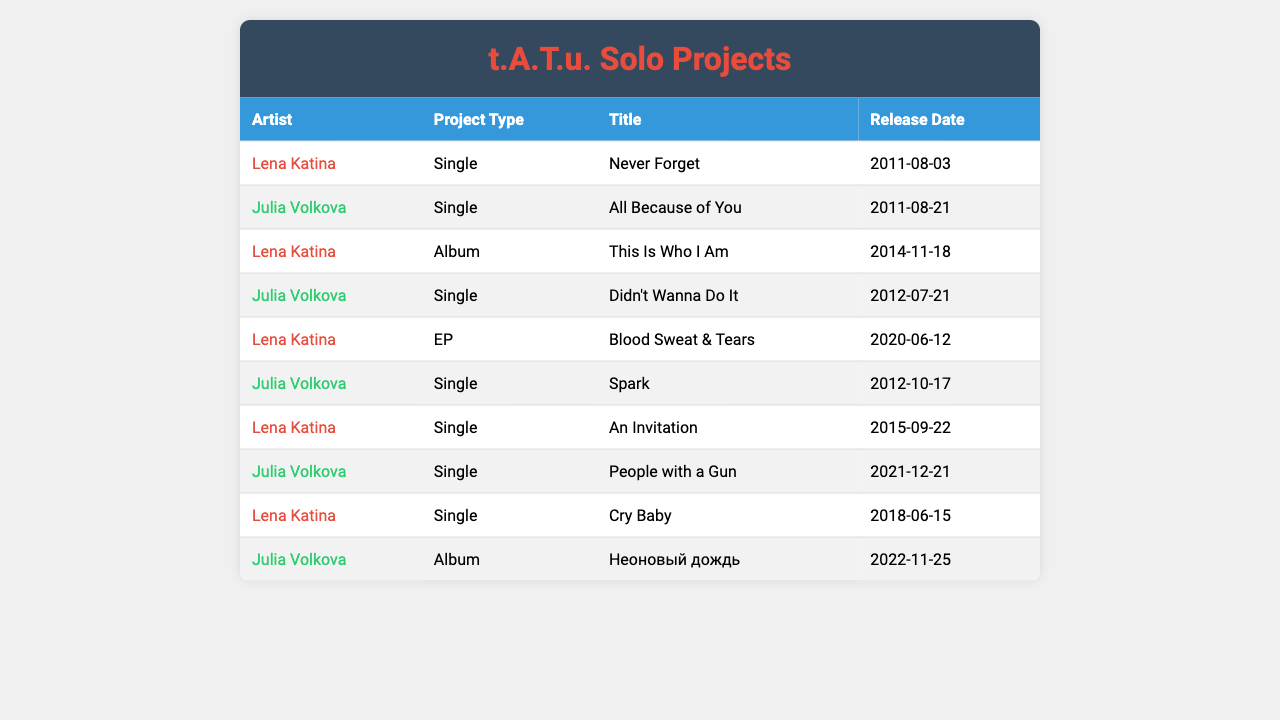What are the titles of the singles released by Lena Katina? From the table, Lena Katina has released the singles "Never Forget," "An Invitation," and "Cry Baby."
Answer: "Never Forget," "An Invitation," "Cry Baby" Which member had an album released later, Lena Katina or Julia Volkova? Lena Katina's album "This Is Who I Am" was released in 2014, while Julia Volkova's album "Неоновый дождь" was released in 2022, making Julia's album the later release.
Answer: Julia Volkova How many singles did Julia Volkova release after the duo's split? Julia Volkova released four singles: "All Because of You," "Didn't Wanna Do It," "Spark," and "People with a Gun."
Answer: Four singles What is the release date of Lena Katina's EP "Blood Sweat & Tears"? The table indicates that Lena Katina's EP "Blood Sweat & Tears" was released on June 12, 2020.
Answer: June 12, 2020 Did Lena Katina release more singles or albums after the duo split? Lena Katina released three singles ("Never Forget," "An Invitation," "Cry Baby") and one album ("This Is Who I Am"), totaling four releases. Since Julia Volkova's count of singles is four, they are equal in the number of singles and albums.
Answer: They are equal Which artist released the single "Spark" and when? According to the table, the single "Spark" was released by Julia Volkova on October 17, 2012.
Answer: Julia Volkova, October 17, 2012 What is the total number of projects released by each artist after the split? Lena Katina released four projects (3 singles, 1 album, 1 EP), and Julia Volkova also released five projects (4 singles, 1 album). Thus, Lena has four and Julia has five.
Answer: Lena Katina: 4, Julia Volkova: 5 Which project type did Lena Katina release most recently? Lena Katina's most recent project is the EP "Blood Sweat & Tears," released on June 12, 2020.
Answer: EP, "Blood Sweat & Tears" Who released a single in 2011, and what was the title? Lena Katina released the single "Never Forget" on August 3, 2011, and Julia Volkova released "All Because of You" on August 21, 2011.
Answer: Lena Katina: "Never Forget"; Julia Volkova: "All Because of You" List all projects by Lena Katina in chronological order. Lena Katina's projects in chronological order are: "Never Forget" (2011), "This Is Who I Am" (2014), "An Invitation" (2015), "Cry Baby" (2018), and "Blood Sweat & Tears" (2020).
Answer: 1. "Never Forget" (2011), 2. "This Is Who I Am" (2014), 3. "An Invitation" (2015), 4. "Cry Baby" (2018), 5. "Blood Sweat & Tears" (2020) 